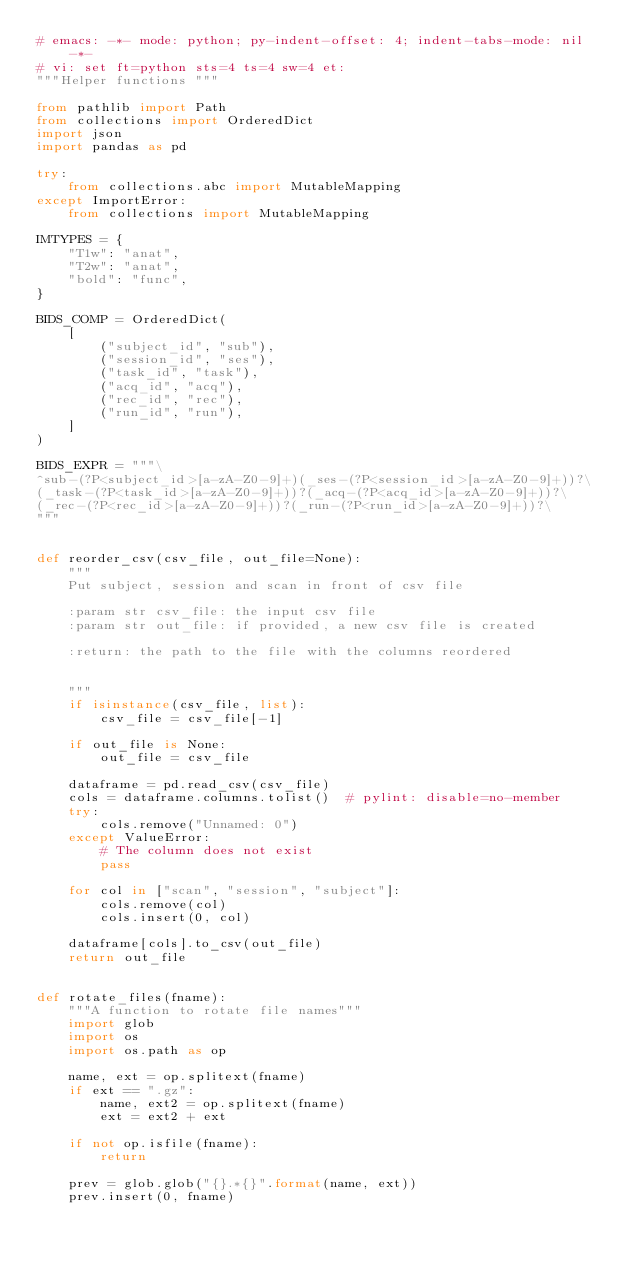<code> <loc_0><loc_0><loc_500><loc_500><_Python_># emacs: -*- mode: python; py-indent-offset: 4; indent-tabs-mode: nil -*-
# vi: set ft=python sts=4 ts=4 sw=4 et:
"""Helper functions """

from pathlib import Path
from collections import OrderedDict
import json
import pandas as pd

try:
    from collections.abc import MutableMapping
except ImportError:
    from collections import MutableMapping

IMTYPES = {
    "T1w": "anat",
    "T2w": "anat",
    "bold": "func",
}

BIDS_COMP = OrderedDict(
    [
        ("subject_id", "sub"),
        ("session_id", "ses"),
        ("task_id", "task"),
        ("acq_id", "acq"),
        ("rec_id", "rec"),
        ("run_id", "run"),
    ]
)

BIDS_EXPR = """\
^sub-(?P<subject_id>[a-zA-Z0-9]+)(_ses-(?P<session_id>[a-zA-Z0-9]+))?\
(_task-(?P<task_id>[a-zA-Z0-9]+))?(_acq-(?P<acq_id>[a-zA-Z0-9]+))?\
(_rec-(?P<rec_id>[a-zA-Z0-9]+))?(_run-(?P<run_id>[a-zA-Z0-9]+))?\
"""


def reorder_csv(csv_file, out_file=None):
    """
    Put subject, session and scan in front of csv file

    :param str csv_file: the input csv file
    :param str out_file: if provided, a new csv file is created

    :return: the path to the file with the columns reordered


    """
    if isinstance(csv_file, list):
        csv_file = csv_file[-1]

    if out_file is None:
        out_file = csv_file

    dataframe = pd.read_csv(csv_file)
    cols = dataframe.columns.tolist()  # pylint: disable=no-member
    try:
        cols.remove("Unnamed: 0")
    except ValueError:
        # The column does not exist
        pass

    for col in ["scan", "session", "subject"]:
        cols.remove(col)
        cols.insert(0, col)

    dataframe[cols].to_csv(out_file)
    return out_file


def rotate_files(fname):
    """A function to rotate file names"""
    import glob
    import os
    import os.path as op

    name, ext = op.splitext(fname)
    if ext == ".gz":
        name, ext2 = op.splitext(fname)
        ext = ext2 + ext

    if not op.isfile(fname):
        return

    prev = glob.glob("{}.*{}".format(name, ext))
    prev.insert(0, fname)</code> 